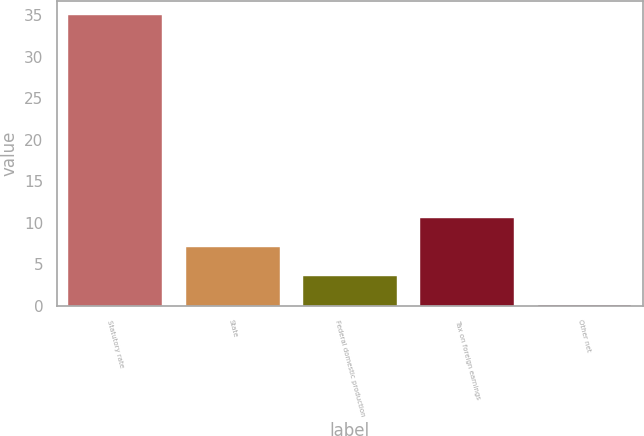<chart> <loc_0><loc_0><loc_500><loc_500><bar_chart><fcel>Statutory rate<fcel>State<fcel>Federal domestic production<fcel>Tax on foreign earnings<fcel>Other net<nl><fcel>35<fcel>7.08<fcel>3.59<fcel>10.57<fcel>0.1<nl></chart> 